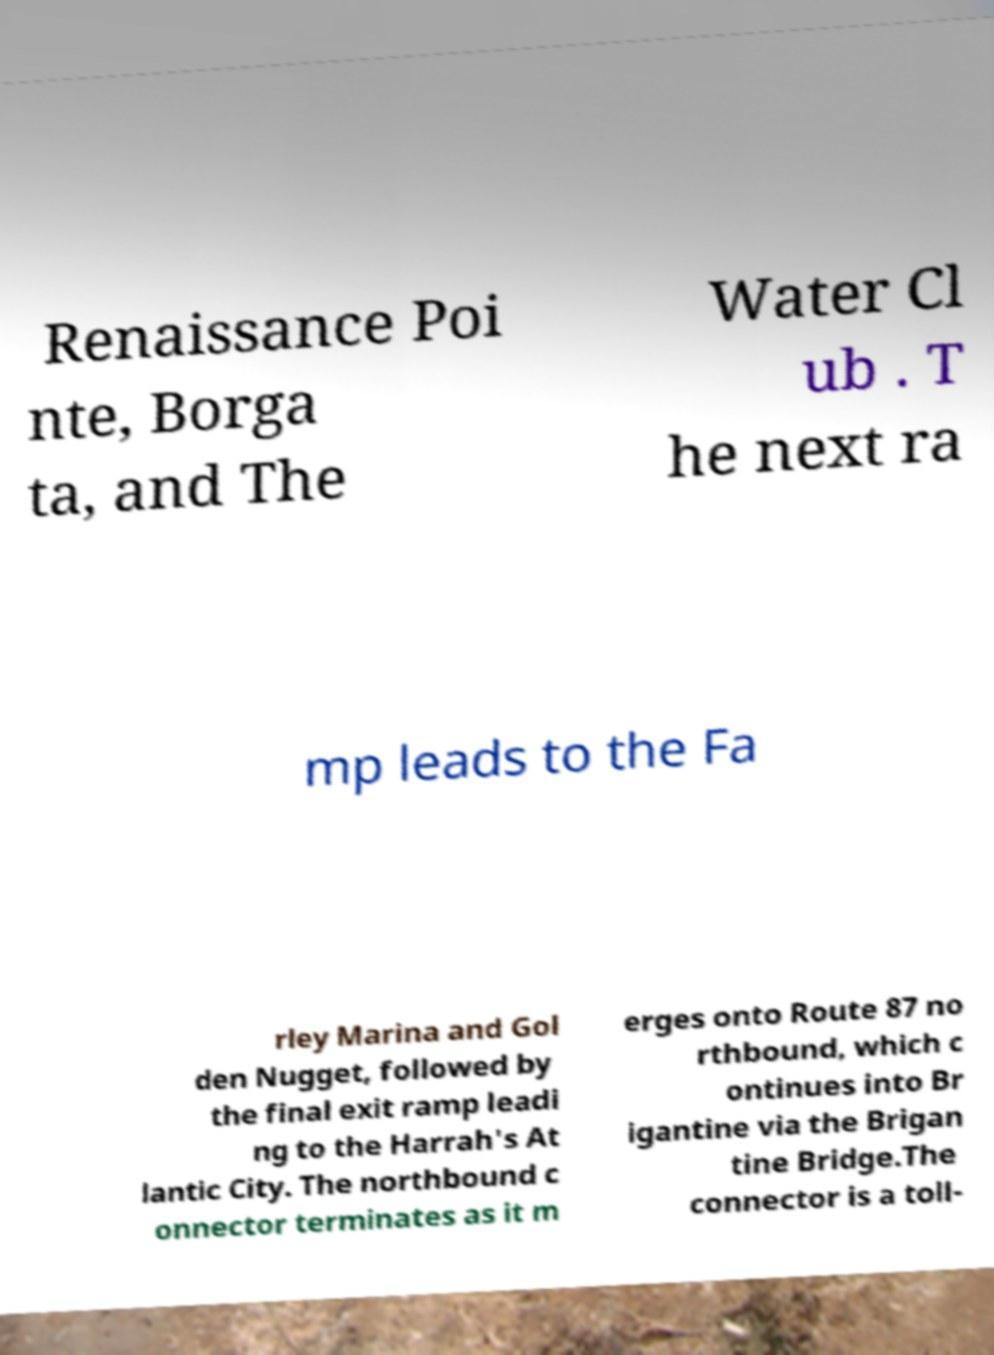Can you read and provide the text displayed in the image?This photo seems to have some interesting text. Can you extract and type it out for me? Renaissance Poi nte, Borga ta, and The Water Cl ub . T he next ra mp leads to the Fa rley Marina and Gol den Nugget, followed by the final exit ramp leadi ng to the Harrah's At lantic City. The northbound c onnector terminates as it m erges onto Route 87 no rthbound, which c ontinues into Br igantine via the Brigan tine Bridge.The connector is a toll- 